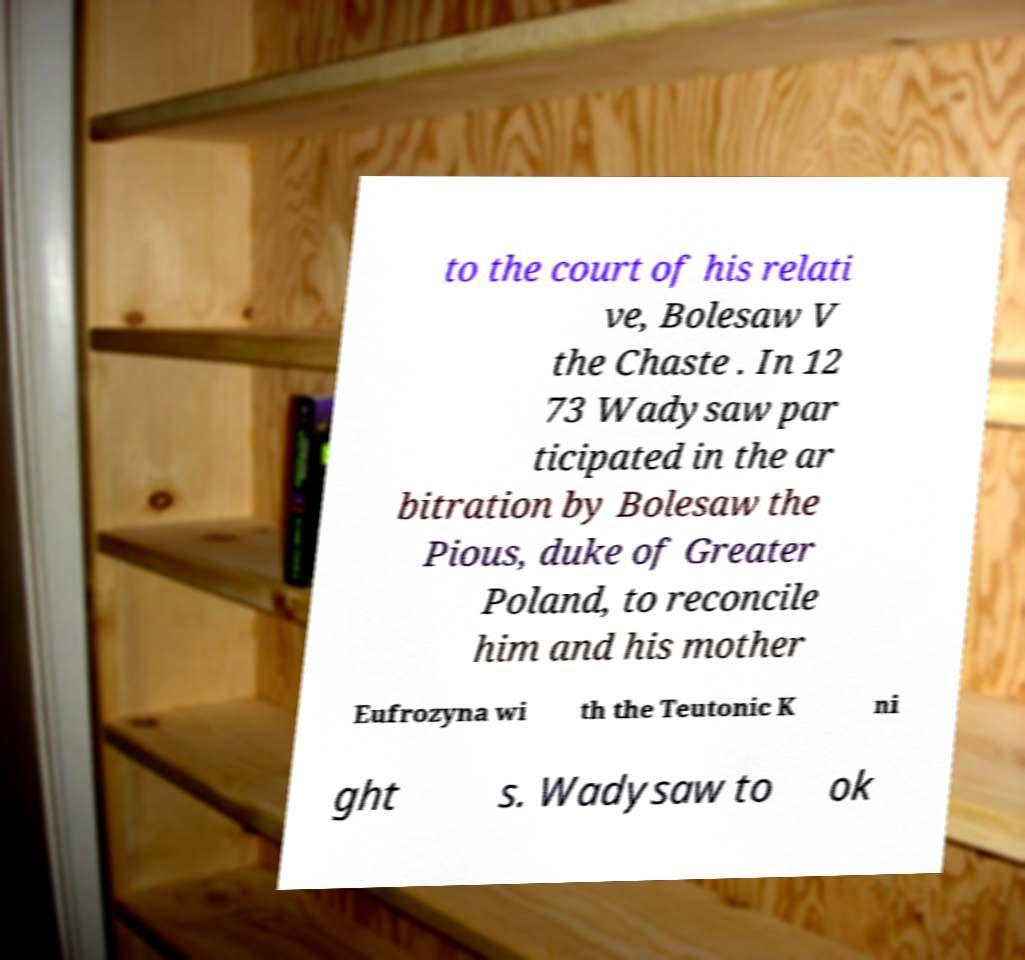Can you accurately transcribe the text from the provided image for me? to the court of his relati ve, Bolesaw V the Chaste . In 12 73 Wadysaw par ticipated in the ar bitration by Bolesaw the Pious, duke of Greater Poland, to reconcile him and his mother Eufrozyna wi th the Teutonic K ni ght s. Wadysaw to ok 